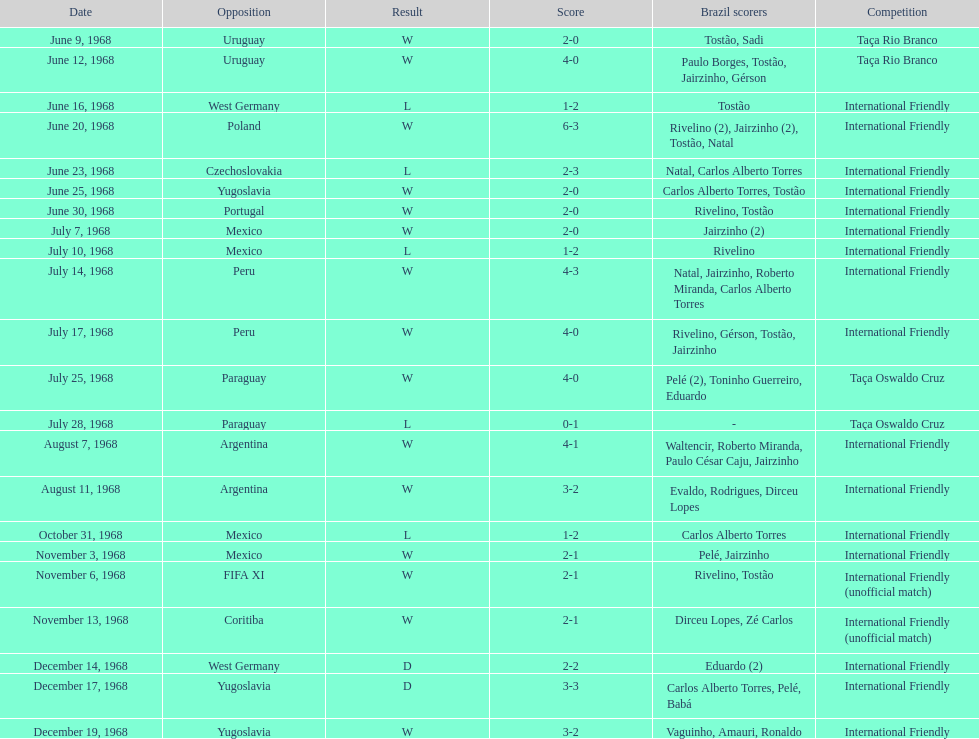Could you help me parse every detail presented in this table? {'header': ['Date', 'Opposition', 'Result', 'Score', 'Brazil scorers', 'Competition'], 'rows': [['June 9, 1968', 'Uruguay', 'W', '2-0', 'Tostão, Sadi', 'Taça Rio Branco'], ['June 12, 1968', 'Uruguay', 'W', '4-0', 'Paulo Borges, Tostão, Jairzinho, Gérson', 'Taça Rio Branco'], ['June 16, 1968', 'West Germany', 'L', '1-2', 'Tostão', 'International Friendly'], ['June 20, 1968', 'Poland', 'W', '6-3', 'Rivelino (2), Jairzinho (2), Tostão, Natal', 'International Friendly'], ['June 23, 1968', 'Czechoslovakia', 'L', '2-3', 'Natal, Carlos Alberto Torres', 'International Friendly'], ['June 25, 1968', 'Yugoslavia', 'W', '2-0', 'Carlos Alberto Torres, Tostão', 'International Friendly'], ['June 30, 1968', 'Portugal', 'W', '2-0', 'Rivelino, Tostão', 'International Friendly'], ['July 7, 1968', 'Mexico', 'W', '2-0', 'Jairzinho (2)', 'International Friendly'], ['July 10, 1968', 'Mexico', 'L', '1-2', 'Rivelino', 'International Friendly'], ['July 14, 1968', 'Peru', 'W', '4-3', 'Natal, Jairzinho, Roberto Miranda, Carlos Alberto Torres', 'International Friendly'], ['July 17, 1968', 'Peru', 'W', '4-0', 'Rivelino, Gérson, Tostão, Jairzinho', 'International Friendly'], ['July 25, 1968', 'Paraguay', 'W', '4-0', 'Pelé (2), Toninho Guerreiro, Eduardo', 'Taça Oswaldo Cruz'], ['July 28, 1968', 'Paraguay', 'L', '0-1', '-', 'Taça Oswaldo Cruz'], ['August 7, 1968', 'Argentina', 'W', '4-1', 'Waltencir, Roberto Miranda, Paulo César Caju, Jairzinho', 'International Friendly'], ['August 11, 1968', 'Argentina', 'W', '3-2', 'Evaldo, Rodrigues, Dirceu Lopes', 'International Friendly'], ['October 31, 1968', 'Mexico', 'L', '1-2', 'Carlos Alberto Torres', 'International Friendly'], ['November 3, 1968', 'Mexico', 'W', '2-1', 'Pelé, Jairzinho', 'International Friendly'], ['November 6, 1968', 'FIFA XI', 'W', '2-1', 'Rivelino, Tostão', 'International Friendly (unofficial match)'], ['November 13, 1968', 'Coritiba', 'W', '2-1', 'Dirceu Lopes, Zé Carlos', 'International Friendly (unofficial match)'], ['December 14, 1968', 'West Germany', 'D', '2-2', 'Eduardo (2)', 'International Friendly'], ['December 17, 1968', 'Yugoslavia', 'D', '3-3', 'Carlos Alberto Torres, Pelé, Babá', 'International Friendly'], ['December 19, 1968', 'Yugoslavia', 'W', '3-2', 'Vaguinho, Amauri, Ronaldo', 'International Friendly']]} In how many games were there wins? 15. 